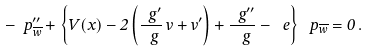<formula> <loc_0><loc_0><loc_500><loc_500>- \ p _ { \overline { w } } ^ { \prime \prime } + \left \{ V ( x ) - 2 \left ( \frac { \ g ^ { \prime } } { \ g } \, v + v ^ { \prime } \right ) + \frac { \ g ^ { \prime \prime } } { \ g } - \ e \right \} \ p _ { \overline { w } } = 0 \, .</formula> 